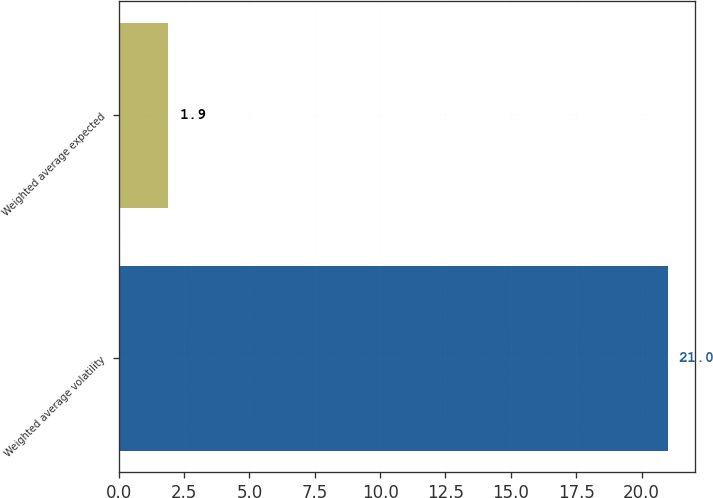<chart> <loc_0><loc_0><loc_500><loc_500><bar_chart><fcel>Weighted average volatility<fcel>Weighted average expected<nl><fcel>21<fcel>1.9<nl></chart> 